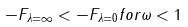<formula> <loc_0><loc_0><loc_500><loc_500>- F _ { \lambda = \infty } < - F _ { \lambda = 0 } f o r \omega < 1</formula> 